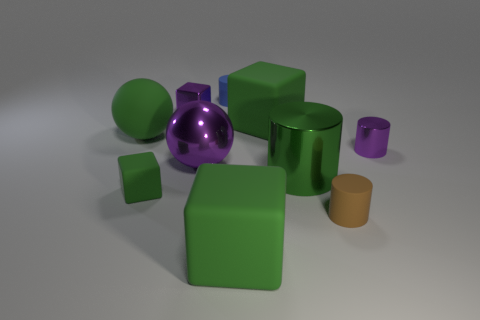Subtract all green cylinders. How many green cubes are left? 3 Subtract 1 cylinders. How many cylinders are left? 3 Subtract all blocks. How many objects are left? 6 Add 3 large green matte things. How many large green matte things are left? 6 Add 9 small yellow matte cubes. How many small yellow matte cubes exist? 9 Subtract 1 purple blocks. How many objects are left? 9 Subtract all red metallic cubes. Subtract all metal blocks. How many objects are left? 9 